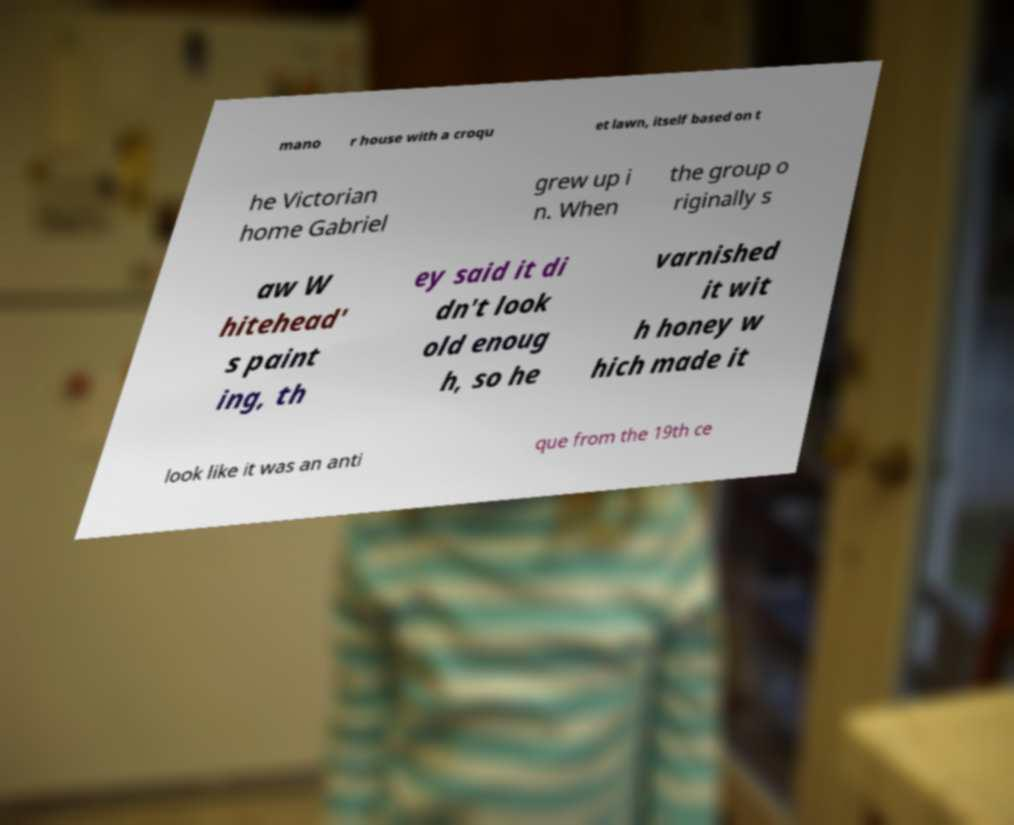Can you read and provide the text displayed in the image?This photo seems to have some interesting text. Can you extract and type it out for me? mano r house with a croqu et lawn, itself based on t he Victorian home Gabriel grew up i n. When the group o riginally s aw W hitehead' s paint ing, th ey said it di dn't look old enoug h, so he varnished it wit h honey w hich made it look like it was an anti que from the 19th ce 